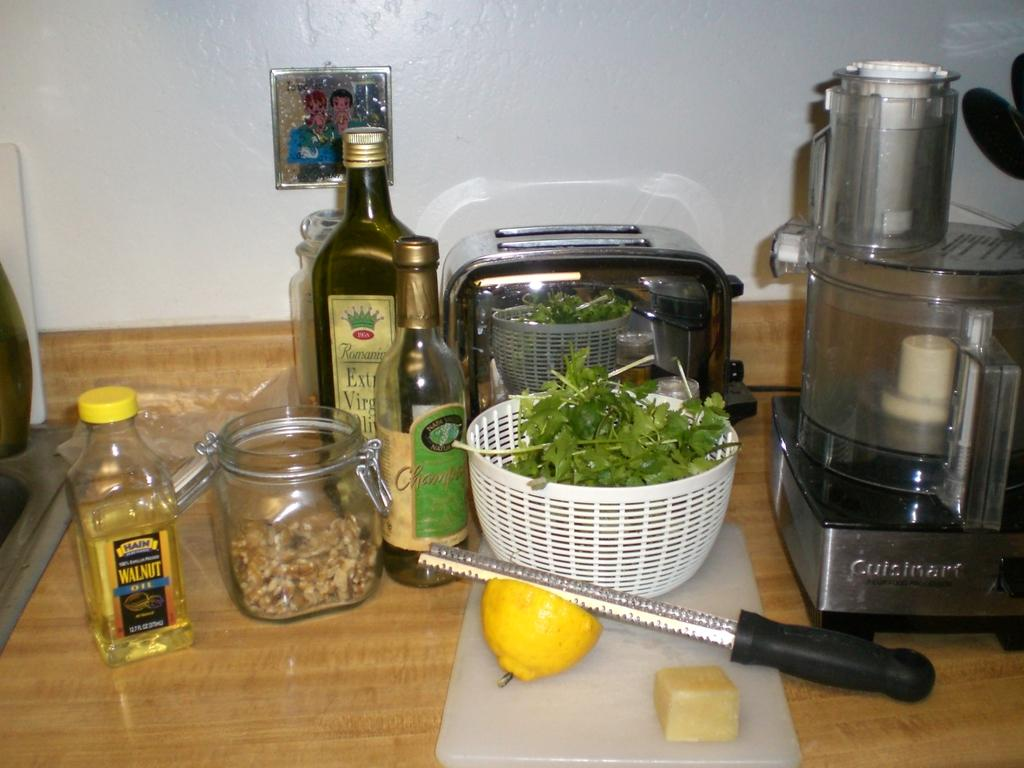<image>
Create a compact narrative representing the image presented. A few cooking ingredients, including walnut oil, Extra Virgin Olive Oil, a lemon, and a Cuisinart blender. 